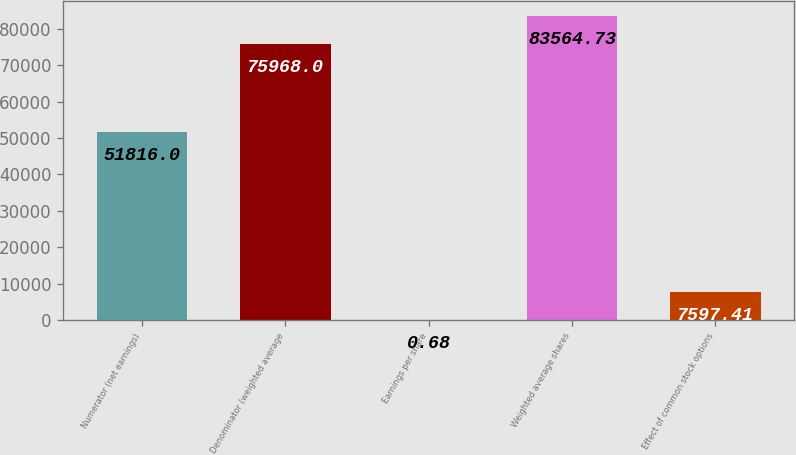Convert chart. <chart><loc_0><loc_0><loc_500><loc_500><bar_chart><fcel>Numerator (net earnings)<fcel>Denominator (weighted average<fcel>Earnings per share<fcel>Weighted average shares<fcel>Effect of common stock options<nl><fcel>51816<fcel>75968<fcel>0.68<fcel>83564.7<fcel>7597.41<nl></chart> 